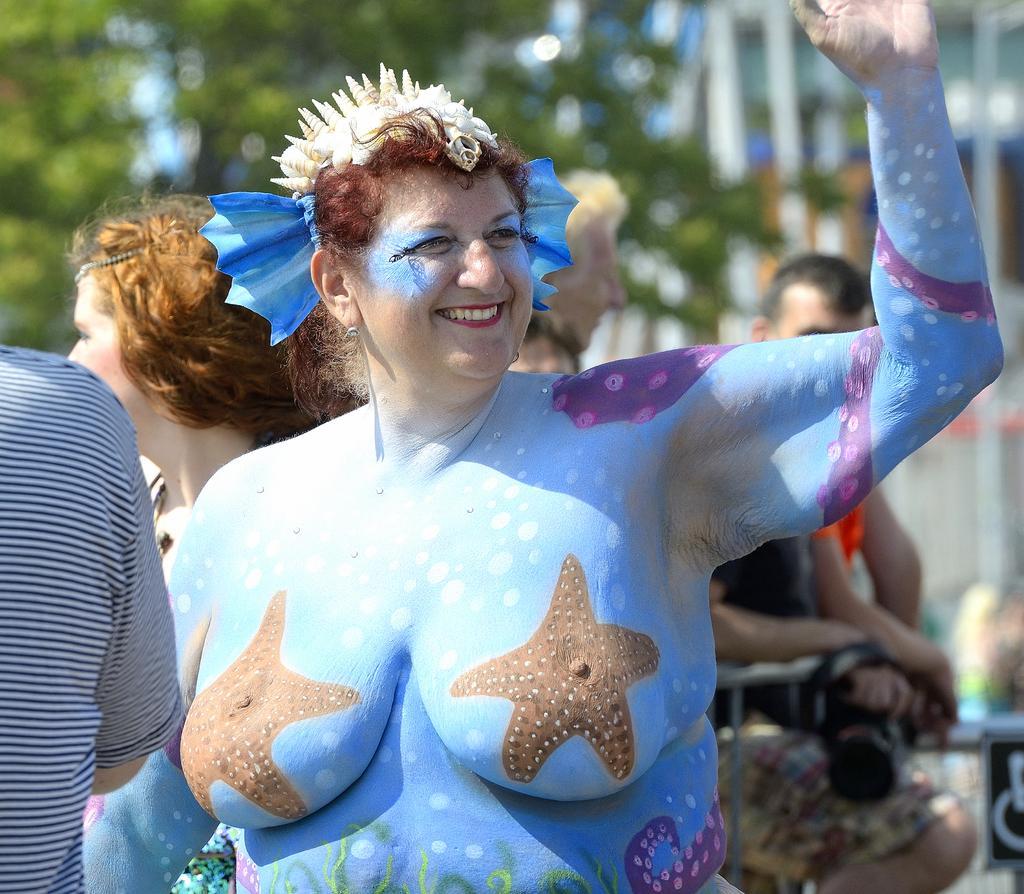Please provide a concise description of this image. In this image, I can see a woman with a painting on her body and few people standing. Behind the people, I can see a tree and the blurred background. 